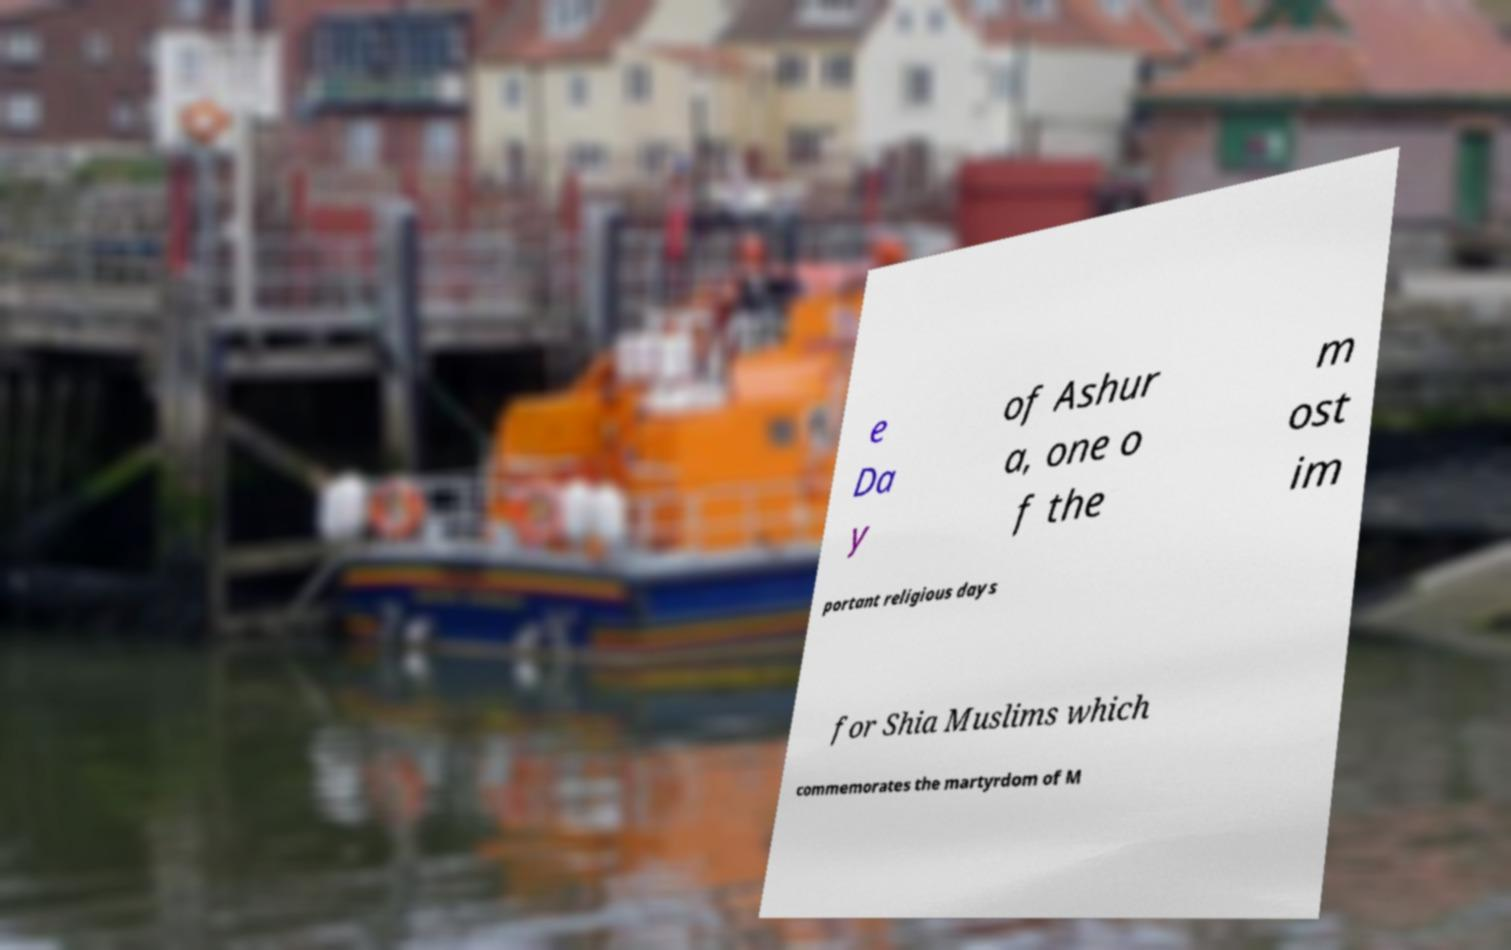Could you assist in decoding the text presented in this image and type it out clearly? e Da y of Ashur a, one o f the m ost im portant religious days for Shia Muslims which commemorates the martyrdom of M 